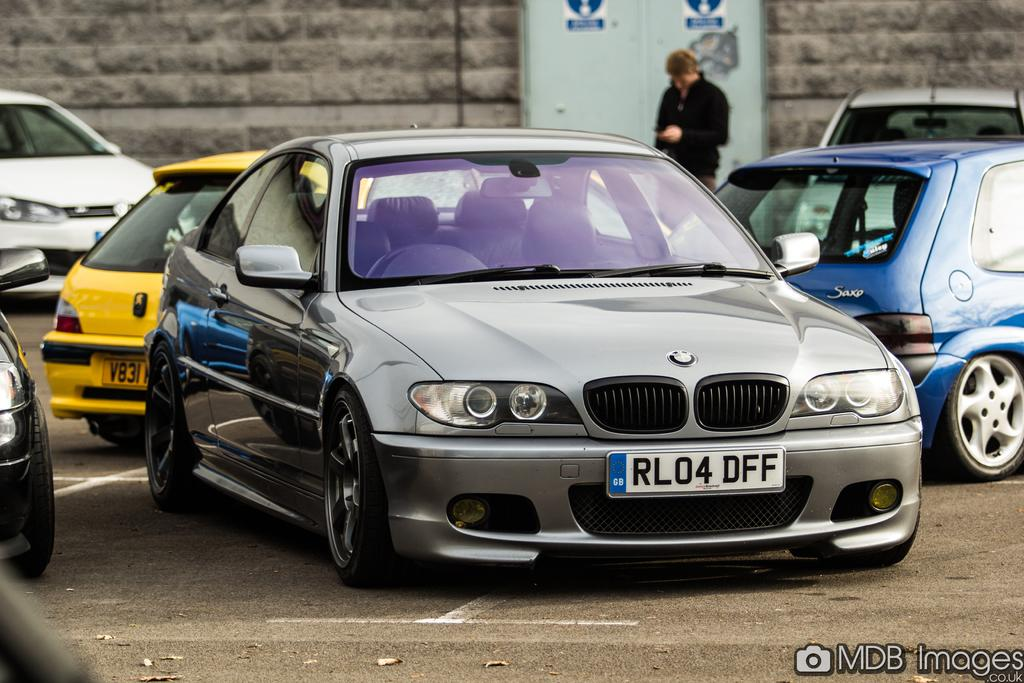<image>
Offer a succinct explanation of the picture presented. A licence plate tHat has the letters RL04DFF 